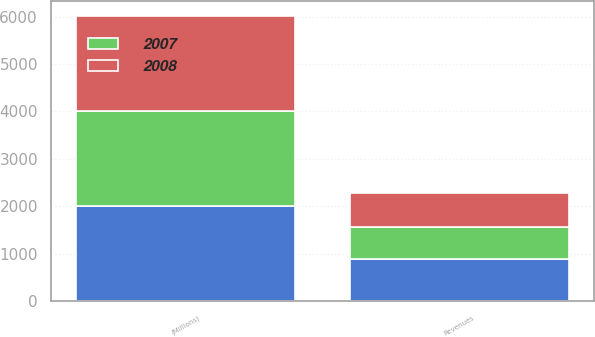Convert chart. <chart><loc_0><loc_0><loc_500><loc_500><stacked_bar_chart><ecel><fcel>(Millions)<fcel>Revenues<nl><fcel>nan<fcel>2008<fcel>885<nl><fcel>2007<fcel>2007<fcel>674<nl><fcel>2008<fcel>2006<fcel>721<nl></chart> 